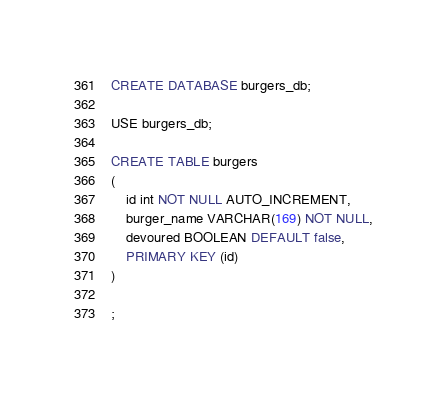Convert code to text. <code><loc_0><loc_0><loc_500><loc_500><_SQL_>CREATE DATABASE burgers_db;

USE burgers_db;

CREATE TABLE burgers
(
    id int NOT NULL AUTO_INCREMENT,
    burger_name VARCHAR(169) NOT NULL,
    devoured BOOLEAN DEFAULT false,
    PRIMARY KEY (id)
)

;</code> 